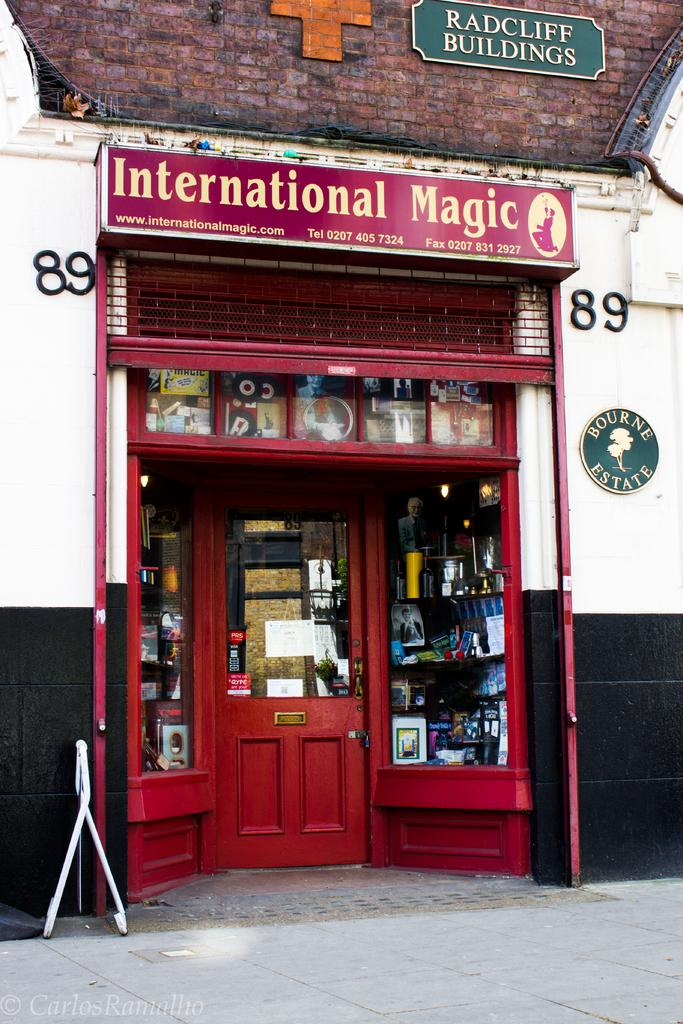What is the main feature of the image? There is a door in the image. What type of structure is shown in the image? The image depicts a building. Can you tell me how many dogs are exchanging treats with their friends in the image? There are no dogs or friends present in the image; it only features a door and a building. 